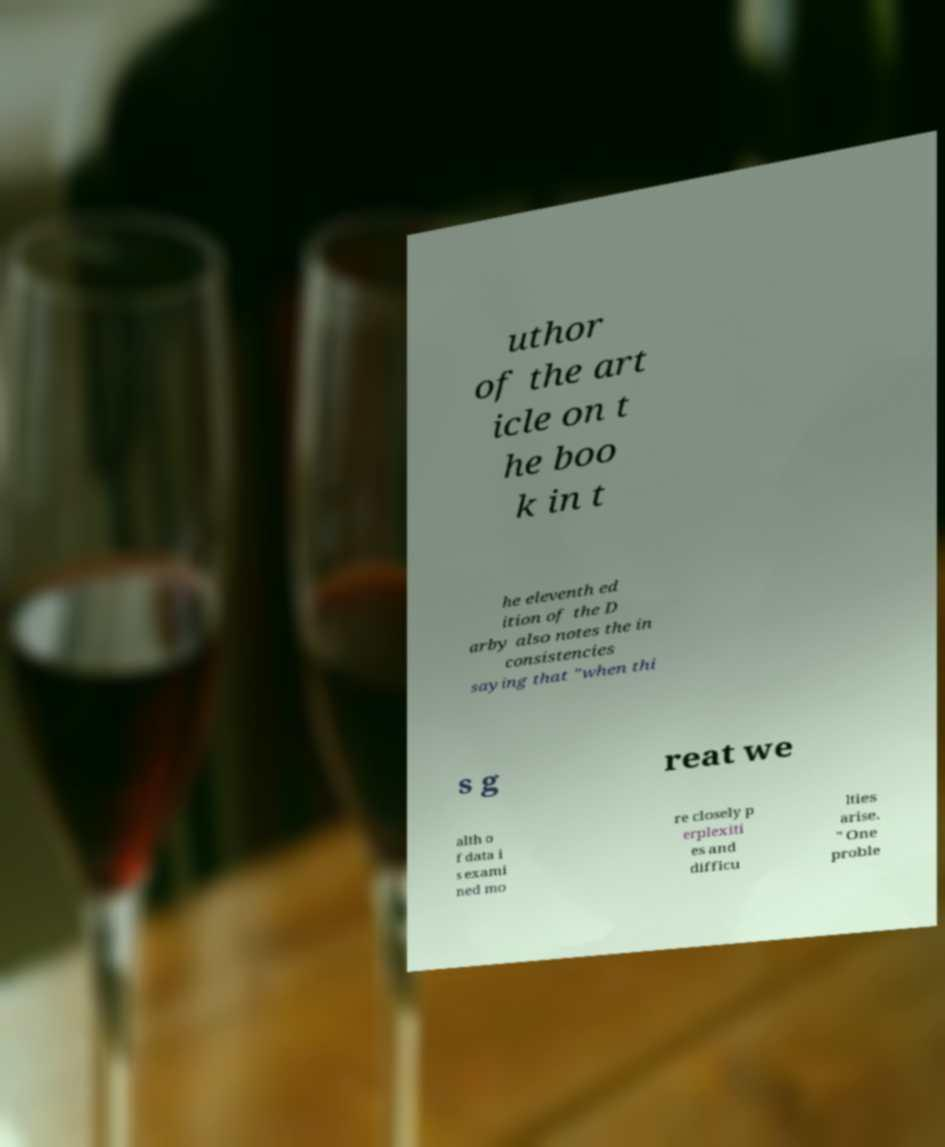There's text embedded in this image that I need extracted. Can you transcribe it verbatim? uthor of the art icle on t he boo k in t he eleventh ed ition of the D arby also notes the in consistencies saying that "when thi s g reat we alth o f data i s exami ned mo re closely p erplexiti es and difficu lties arise. " One proble 